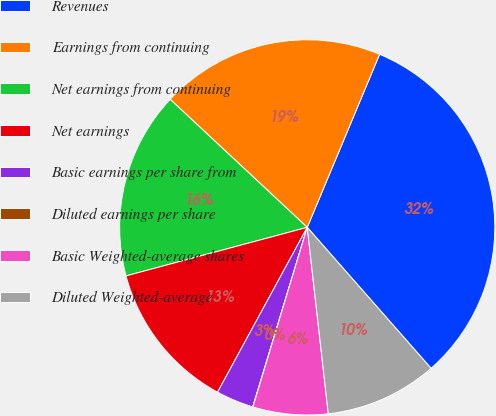<chart> <loc_0><loc_0><loc_500><loc_500><pie_chart><fcel>Revenues<fcel>Earnings from continuing<fcel>Net earnings from continuing<fcel>Net earnings<fcel>Basic earnings per share from<fcel>Diluted earnings per share<fcel>Basic Weighted-average shares<fcel>Diluted Weighted-average<nl><fcel>32.22%<fcel>19.34%<fcel>16.12%<fcel>12.9%<fcel>3.24%<fcel>0.02%<fcel>6.46%<fcel>9.68%<nl></chart> 